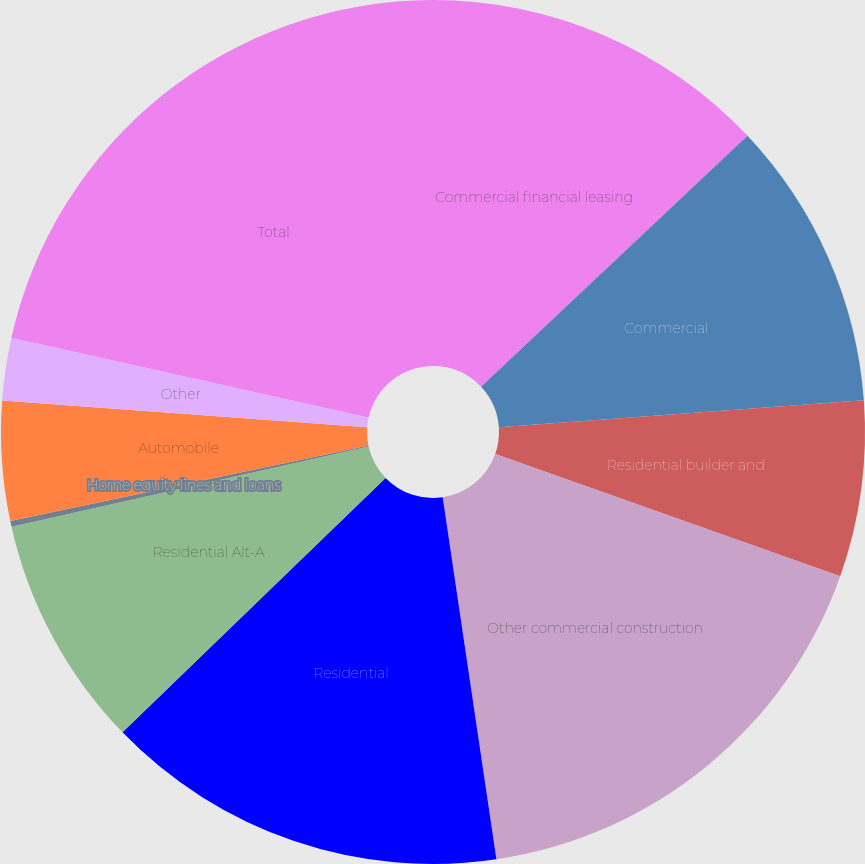Convert chart to OTSL. <chart><loc_0><loc_0><loc_500><loc_500><pie_chart><fcel>Commercial financial leasing<fcel>Commercial<fcel>Residential builder and<fcel>Other commercial construction<fcel>Residential<fcel>Residential Alt-A<fcel>Home equity lines and loans<fcel>Automobile<fcel>Other<fcel>Total<nl><fcel>12.98%<fcel>10.85%<fcel>6.59%<fcel>17.24%<fcel>15.11%<fcel>8.72%<fcel>0.21%<fcel>4.47%<fcel>2.34%<fcel>21.5%<nl></chart> 